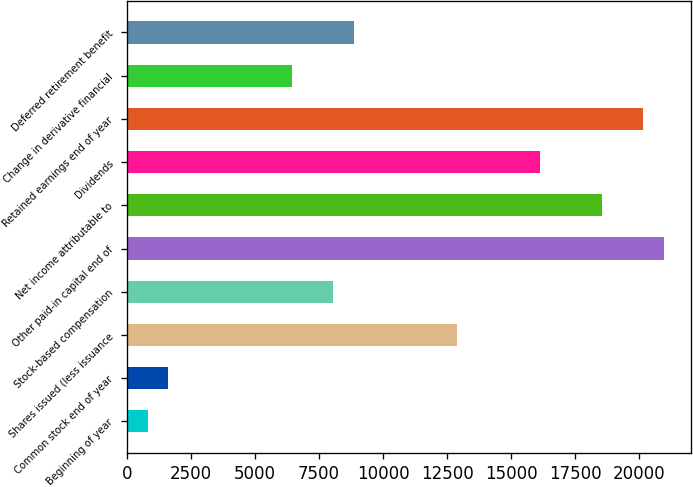<chart> <loc_0><loc_0><loc_500><loc_500><bar_chart><fcel>Beginning of year<fcel>Common stock end of year<fcel>Shares issued (less issuance<fcel>Stock-based compensation<fcel>Other paid-in capital end of<fcel>Net income attributable to<fcel>Dividends<fcel>Retained earnings end of year<fcel>Change in derivative financial<fcel>Deferred retirement benefit<nl><fcel>807.7<fcel>1614.4<fcel>12908.2<fcel>8068<fcel>20975.2<fcel>18555.1<fcel>16135<fcel>20168.5<fcel>6454.6<fcel>8874.7<nl></chart> 